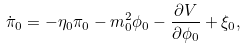<formula> <loc_0><loc_0><loc_500><loc_500>\dot { \pi } _ { 0 } = - \eta _ { 0 } \pi _ { 0 } - m _ { 0 } ^ { 2 } \phi _ { 0 } - \frac { \partial V } { \partial \phi _ { 0 } } + \xi _ { 0 } ,</formula> 